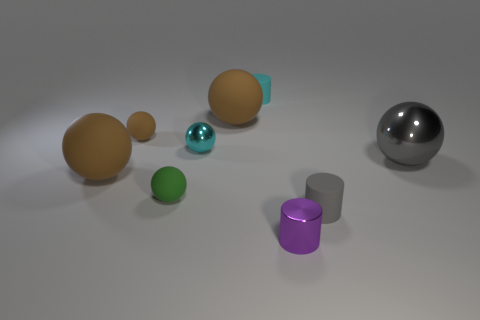There is a brown object that is behind the big gray metal sphere and left of the cyan shiny thing; what material is it made of?
Make the answer very short. Rubber. Is the number of green rubber balls less than the number of tiny red cylinders?
Your answer should be very brief. No. Do the small green rubber thing and the purple object that is to the left of the big gray sphere have the same shape?
Give a very brief answer. No. There is a cylinder to the right of the purple object; is its size the same as the large metal sphere?
Make the answer very short. No. There is a brown matte object that is the same size as the gray cylinder; what is its shape?
Provide a succinct answer. Sphere. Is the big gray metal thing the same shape as the small purple thing?
Keep it short and to the point. No. What number of other cyan objects are the same shape as the big shiny thing?
Give a very brief answer. 1. There is a metallic cylinder; how many small brown balls are in front of it?
Give a very brief answer. 0. There is a tiny sphere that is in front of the tiny cyan ball; is its color the same as the big metal ball?
Make the answer very short. No. How many cyan spheres are the same size as the metallic cylinder?
Offer a terse response. 1. 